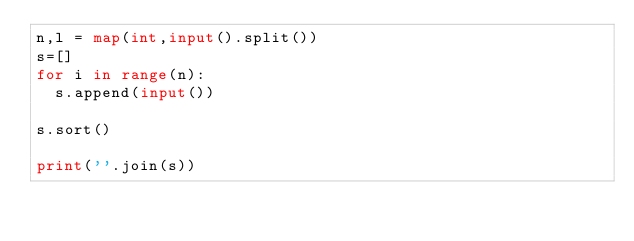<code> <loc_0><loc_0><loc_500><loc_500><_Python_>n,l = map(int,input().split())
s=[]
for i in range(n):
  s.append(input())
  
s.sort()

print(''.join(s))</code> 